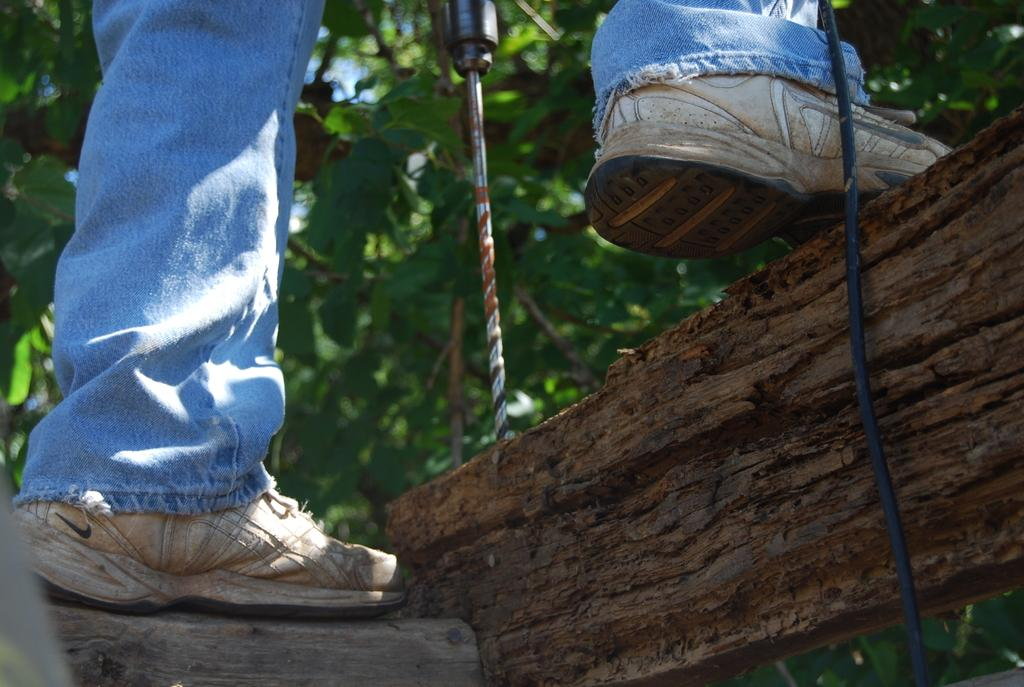What is the main focus of the image? The main focus of the image is a person's legs in the center. What else can be seen on the right side of the image? There is a wire on the right side of the image. What is the person doing in the image? The person is using a driller in the center of the image. What can be seen in the background of the image? There are trees in the background of the image. What color is the marble that the person is holding in the image? There is no marble present in the image; the person is using a driller. What type of wound can be seen on the person's leg in the image? There is no wound visible on the person's leg in the image. 